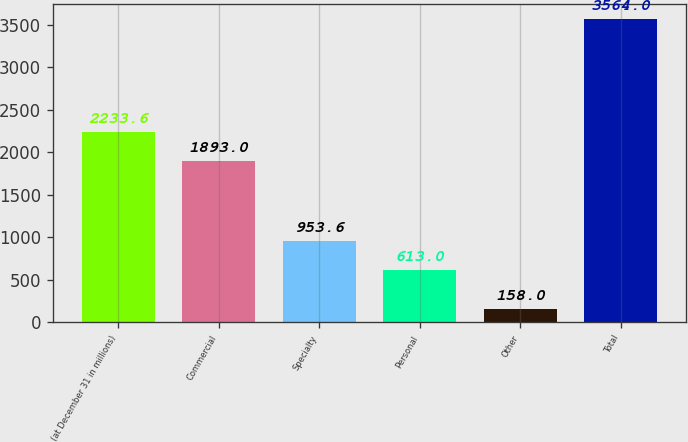<chart> <loc_0><loc_0><loc_500><loc_500><bar_chart><fcel>(at December 31 in millions)<fcel>Commercial<fcel>Specialty<fcel>Personal<fcel>Other<fcel>Total<nl><fcel>2233.6<fcel>1893<fcel>953.6<fcel>613<fcel>158<fcel>3564<nl></chart> 